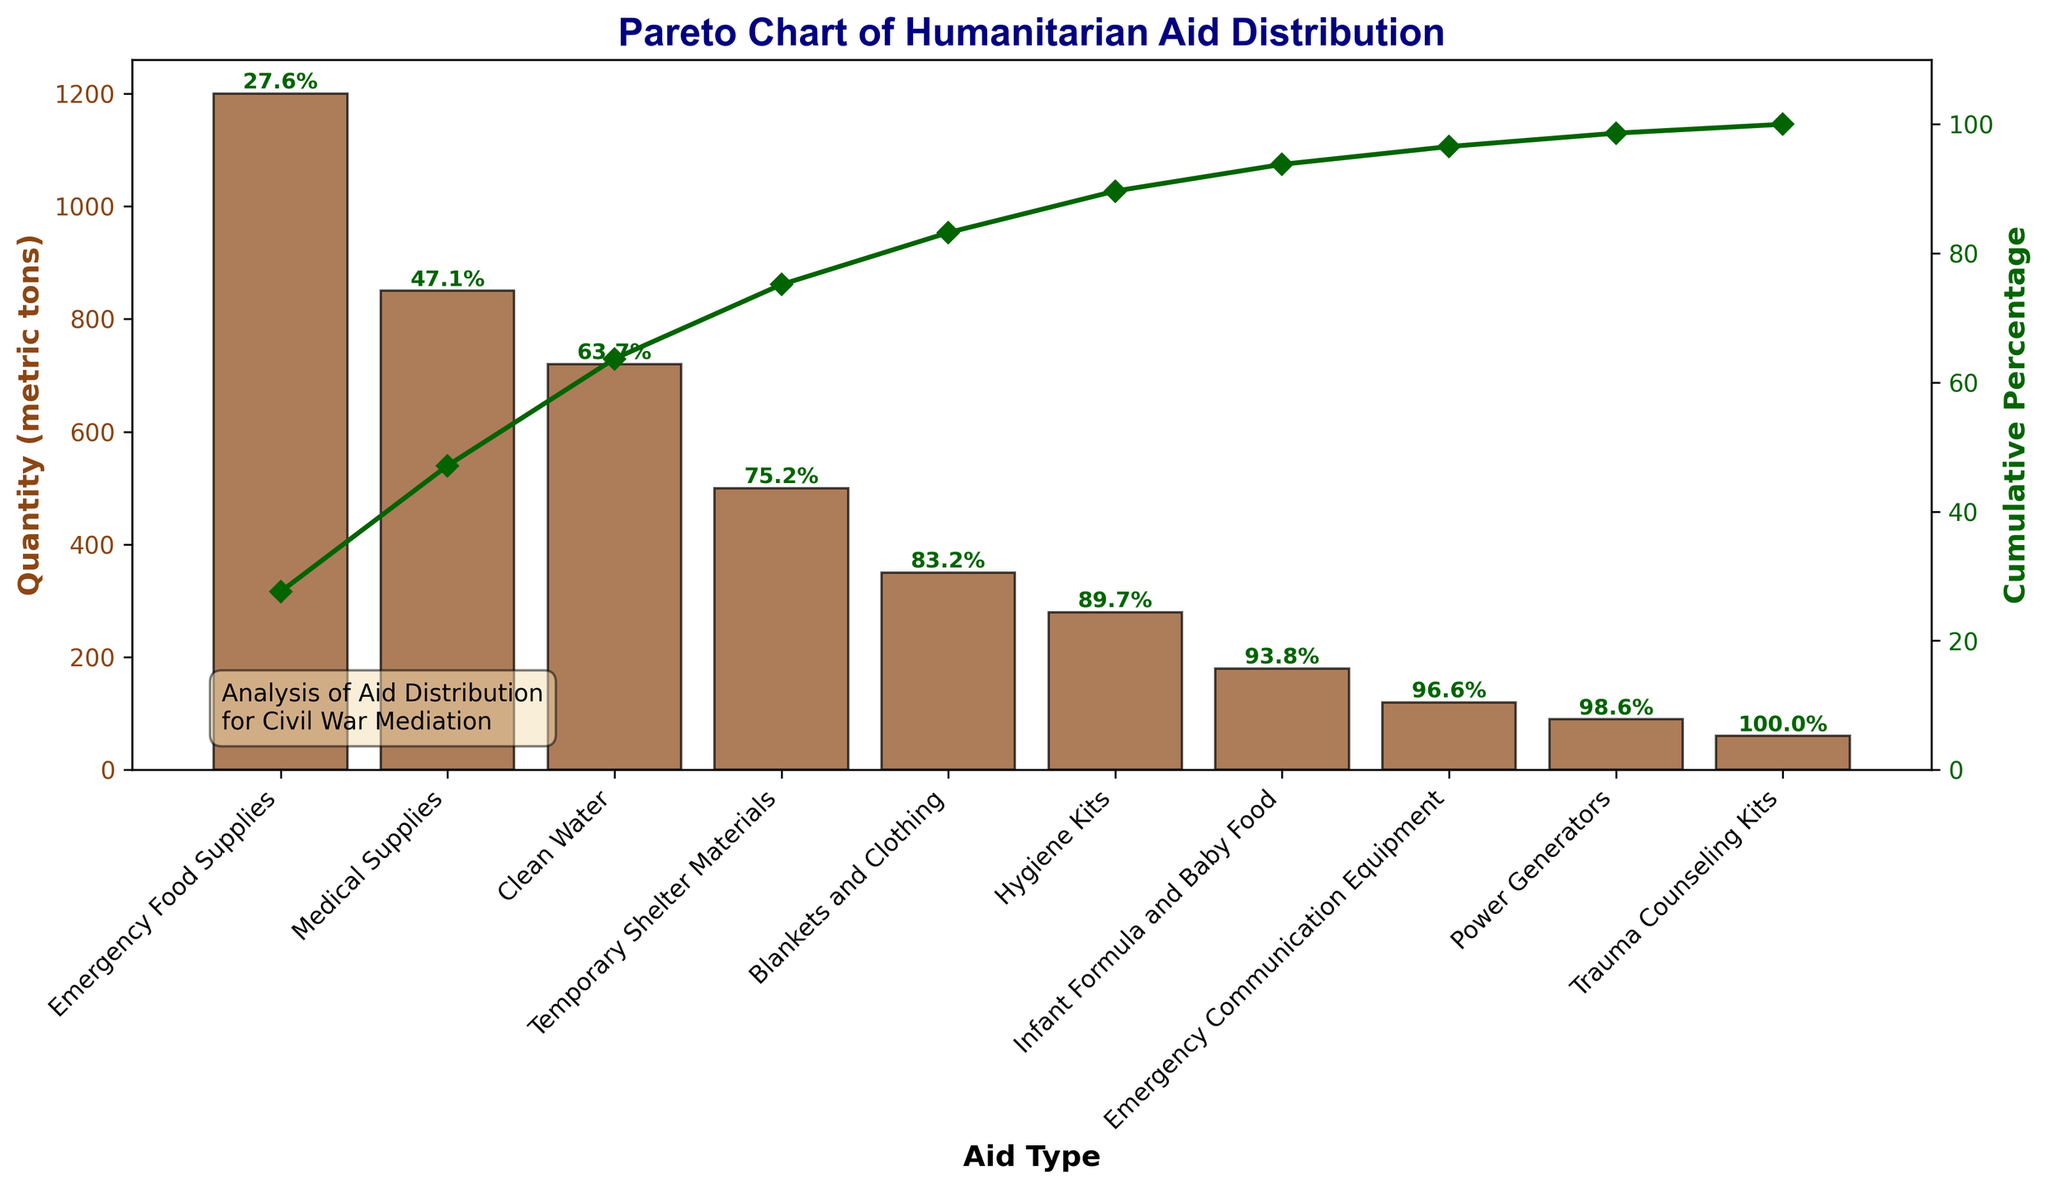What is the title of the figure? The title of the figure is displayed at the top. It reads "Pareto Chart of Humanitarian Aid Distribution".
Answer: Pareto Chart of Humanitarian Aid Distribution What does the x-axis represent? The x-axis represents different "Aid Types". These are categories of humanitarian aid delivered.
Answer: Aid Types What does the y-axis on the left represent? The left y-axis represents the "Quantity (metric tons)" of each type of aid delivered.
Answer: Quantity (metric tons) What does the y-axis on the right represent? The right y-axis represents the "Cumulative Percentage" of the total quantity of aid delivered.
Answer: Cumulative Percentage How many types of aid are represented in the chart? By counting the bars along the x-axis, we can see that there are ten types of aid represented in the chart.
Answer: 10 What is the total quantity of the top three types of aid combined? The quantities of the top three types of aid are: Emergency Food Supplies (1200 metric tons), Medical Supplies (850 metric tons), and Clean Water (720 metric tons). Adding these together: 1200 + 850 + 720 = 2770 metric tons.
Answer: 2770 metric tons What is the average quantity of aid for the bottom five types? The quantities for the bottom five types are: Blankets and Clothing (350 metric tons), Hygiene Kits (280 metric tons), Infant Formula and Baby Food (180 metric tons), Emergency Communication Equipment (120 metric tons), and Power Generators (90 metric tons). Add these together: 350 + 280 + 180 + 120 + 90 = 1020. There are 5 types, so: 1020 / 5 = 204 metric tons on average.
Answer: 204 metric tons Which type of aid has the highest quantity? The bar representing "Emergency Food Supplies" is the tallest, indicating it has the highest quantity of 1200 metric tons.
Answer: Emergency Food Supplies Which type of aid has the lowest quantity? The bar representing "Trauma Counseling Kits" is the shortest, indicating it has the lowest quantity of 60 metric tons.
Answer: Trauma Counseling Kits Which type of aid contributes to achieving over 80% of the cumulative percentage first? Following the cumulative percentage line (the green line) and finding the first aid type where the cumulative percentage surpasses 80%, we see that "Temporary Shelter Materials" marks the point where cumulative percentage first exceeds 80%.
Answer: Temporary Shelter Materials What is the cumulative percentage after Emergency Food Supplies and Medical Supplies? By looking at the green cumulative percentage line, after Emergency Food Supplies and Medical Supplies, the cumulative percentage is just above 50%. Specifically, the cumulative percentage is 50.2%.
Answer: 50.2% Which two types of aid account for approximately 60% of the total quantity? Observing the green line, we see that the quantities of Emergency Food Supplies and Medical Supplies leave us just under 60%, which is then exceeded slightly by adding Clean Water. Therefore, Emergency Food Supplies and Medical Supplies together account for approximately 60%.
Answer: Emergency Food Supplies and Medical Supplies 